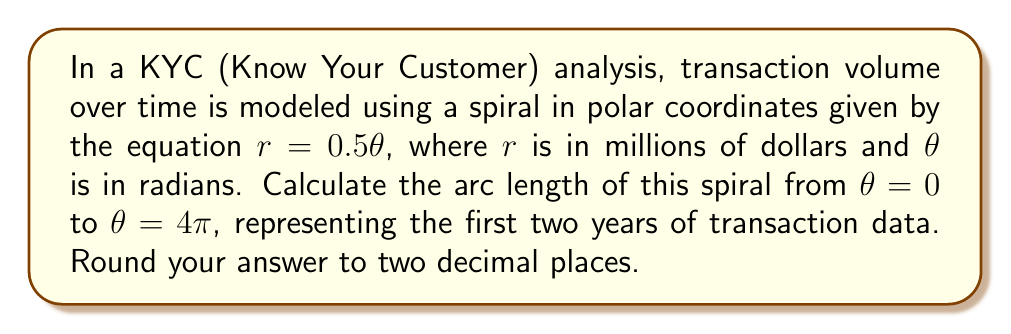Could you help me with this problem? To calculate the arc length of a spiral in polar coordinates, we use the formula:

$$L = \int_a^b \sqrt{r^2 + \left(\frac{dr}{d\theta}\right)^2} d\theta$$

Where:
- $L$ is the arc length
- $r$ is the radius as a function of $\theta$
- $a$ and $b$ are the starting and ending angles

For our spiral, $r = 0.5\theta$, so:

1) First, we need to find $\frac{dr}{d\theta}$:
   $\frac{dr}{d\theta} = 0.5$

2) Now, let's substitute these into our arc length formula:
   $$L = \int_0^{4\pi} \sqrt{(0.5\theta)^2 + (0.5)^2} d\theta$$

3) Simplify inside the square root:
   $$L = \int_0^{4\pi} \sqrt{0.25\theta^2 + 0.25} d\theta$$

4) Factor out 0.25:
   $$L = \int_0^{4\pi} \sqrt{0.25(\theta^2 + 1)} d\theta$$

5) Simplify:
   $$L = 0.5 \int_0^{4\pi} \sqrt{\theta^2 + 1} d\theta$$

6) This integral doesn't have an elementary antiderivative. We need to use the hyperbolic functions:
   $$L = 0.5 \left[\frac{\theta}{2}\sqrt{\theta^2+1} + \frac{1}{2}\ln(\theta + \sqrt{\theta^2+1})\right]_0^{4\pi}$$

7) Evaluate at the limits:
   $$L = 0.5 \left[\frac{4\pi}{2}\sqrt{(4\pi)^2+1} + \frac{1}{2}\ln(4\pi + \sqrt{(4\pi)^2+1}) - (0 + 0)\right]$$

8) Simplify and calculate (using a calculator):
   $$L \approx 25.13$$

Rounding to two decimal places, we get 25.13 million dollars.
Answer: $25.13$ million dollars 